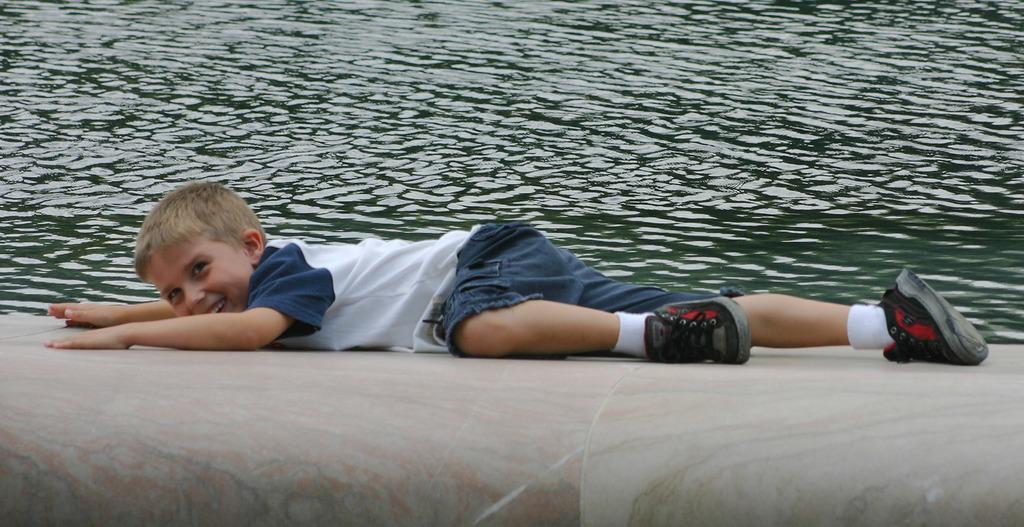Could you give a brief overview of what you see in this image? In this image we can see a boy lying on the surface and we can also see water. 